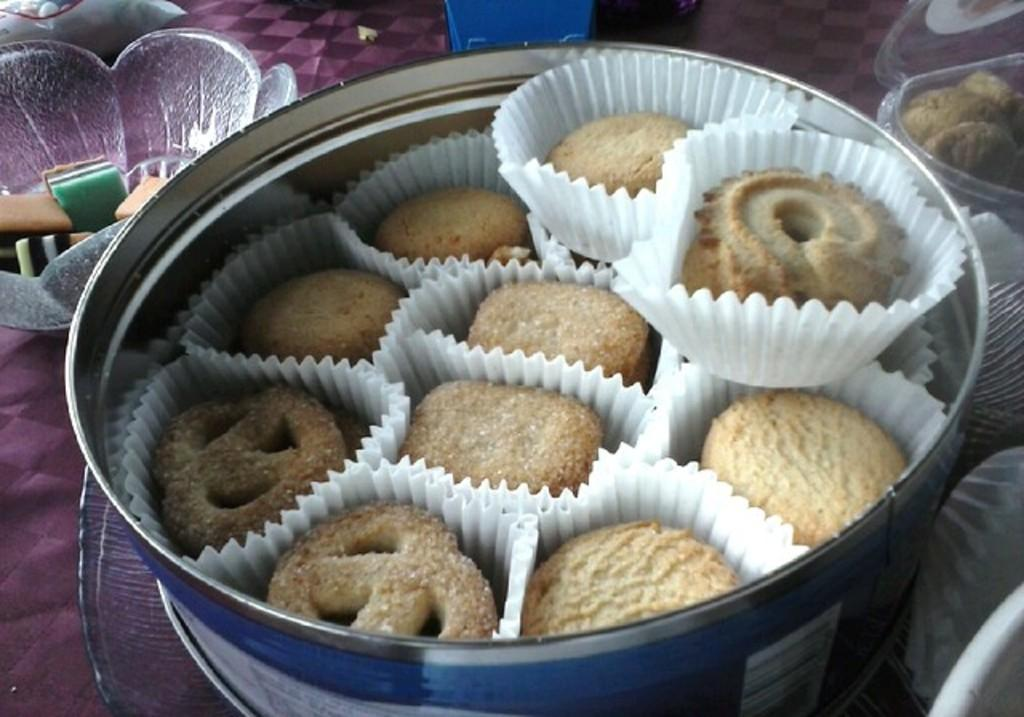What is the main subject of the image? The main subject of the image is food items arranged in bowls. Where are the bowls located in the image? The bowls are placed on a table in the image. Can you describe any other objects present in the image? Unfortunately, the provided facts do not specify any other objects present in the image. What type of selection is being celebrated in the afternoon? There is no mention of a selection or an afternoon celebration in the image. 